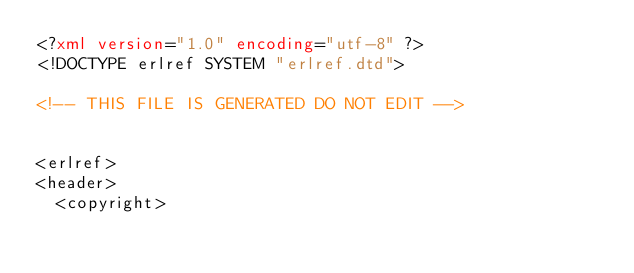<code> <loc_0><loc_0><loc_500><loc_500><_XML_><?xml version="1.0" encoding="utf-8" ?>
<!DOCTYPE erlref SYSTEM "erlref.dtd">

<!-- THIS FILE IS GENERATED DO NOT EDIT -->


<erlref>
<header>
  <copyright></code> 